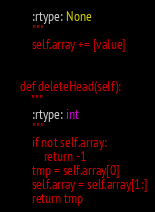<code> <loc_0><loc_0><loc_500><loc_500><_Python_>        :rtype: None
        """
        self.array += [value]


    def deleteHead(self):
        """
        :rtype: int
        """
        if not self.array:
            return -1
        tmp = self.array[0]
        self.array = self.array[1:]
        return tmp
</code> 